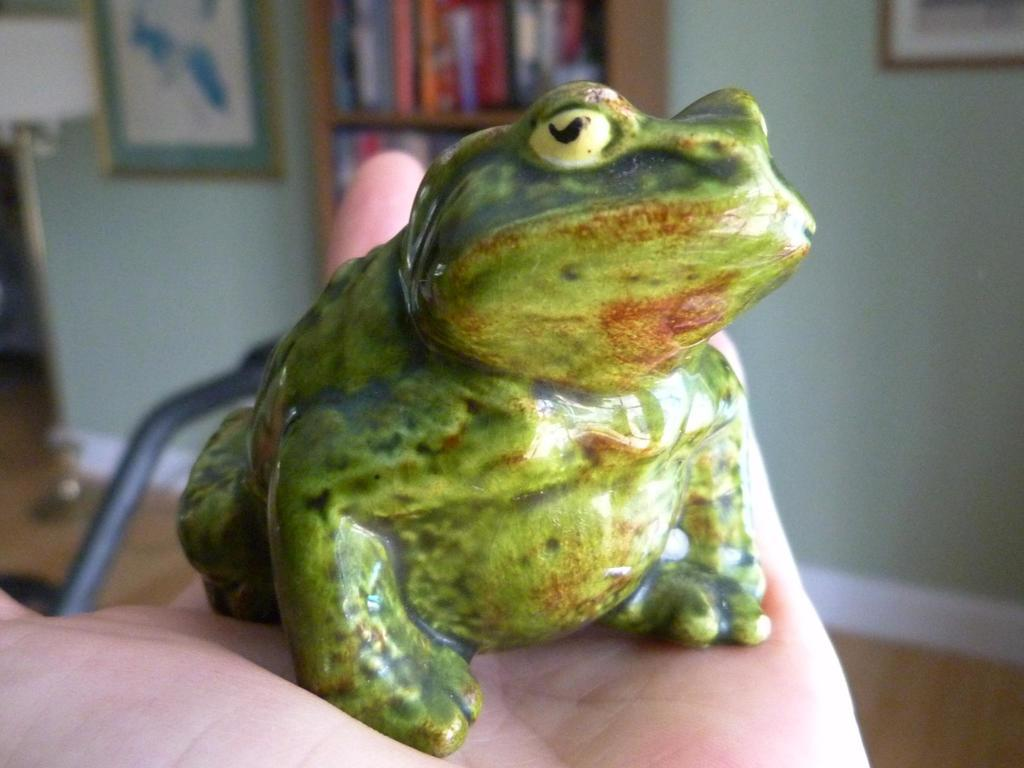What type of toy is in the image? There is a toy frog in the image. Where is the toy frog located? The toy frog is on a person's hand. What can be seen in the background of the image? There is a cupboard and frames on the wall in the background of the image. What type of songs can be heard playing in the background of the image? There is no audio or music present in the image, so it is not possible to determine what songs might be heard. 